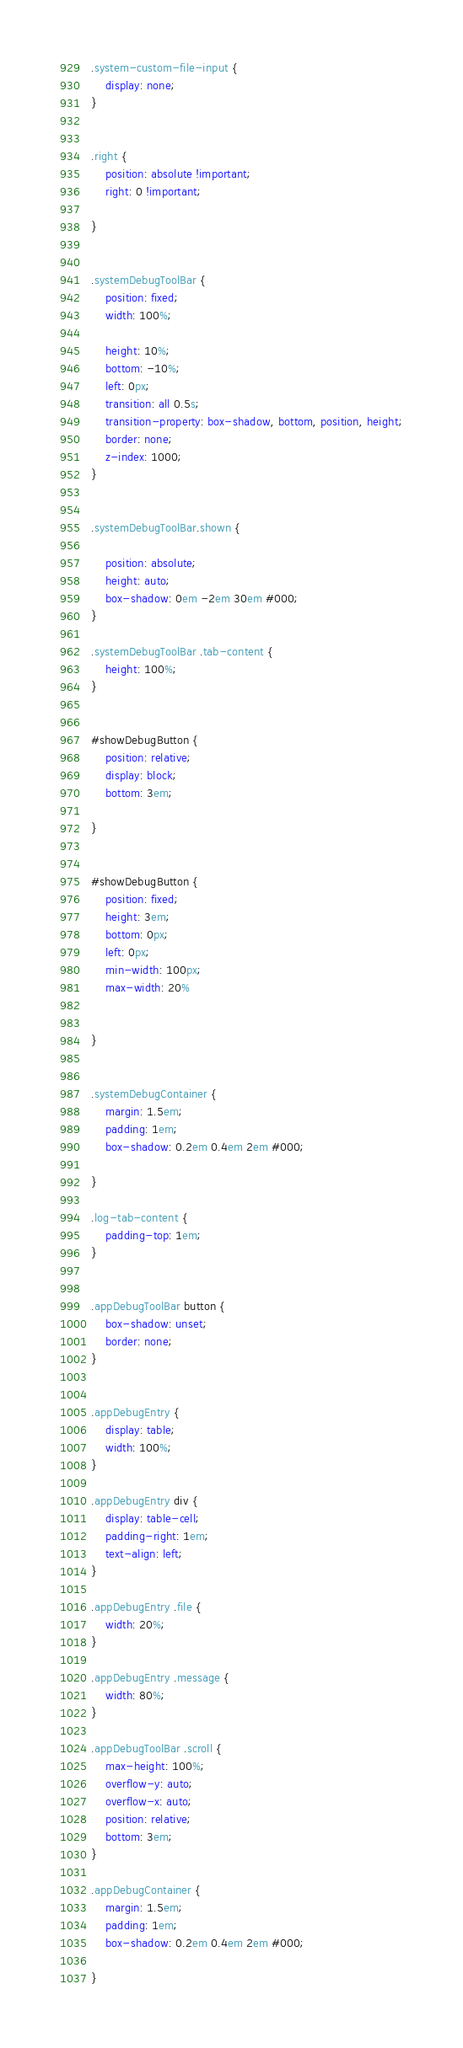<code> <loc_0><loc_0><loc_500><loc_500><_CSS_>.system-custom-file-input {
    display: none;
}


.right {
    position: absolute !important;
    right: 0 !important;

}


.systemDebugToolBar {
    position: fixed;
    width: 100%;

    height: 10%;
    bottom: -10%;
    left: 0px;
    transition: all 0.5s;
    transition-property: box-shadow, bottom, position, height;
    border: none;
    z-index: 1000;
}


.systemDebugToolBar.shown {

    position: absolute;
    height: auto;
    box-shadow: 0em -2em 30em #000;
}

.systemDebugToolBar .tab-content {
    height: 100%;
}


#showDebugButton {
    position: relative;
    display: block;
    bottom: 3em;

}


#showDebugButton {
    position: fixed;
    height: 3em;
    bottom: 0px;
    left: 0px;
    min-width: 100px;
    max-width: 20%


}


.systemDebugContainer {
    margin: 1.5em;
    padding: 1em;
    box-shadow: 0.2em 0.4em 2em #000;

}

.log-tab-content {
    padding-top: 1em;
}


.appDebugToolBar button {
    box-shadow: unset;
    border: none;
}


.appDebugEntry {
    display: table;
    width: 100%;
}

.appDebugEntry div {
    display: table-cell;
    padding-right: 1em;
    text-align: left;
}

.appDebugEntry .file {
    width: 20%;
}

.appDebugEntry .message {
    width: 80%;
}

.appDebugToolBar .scroll {
    max-height: 100%;
    overflow-y: auto;
    overflow-x: auto;
    position: relative;
    bottom: 3em;
}

.appDebugContainer {
    margin: 1.5em;
    padding: 1em;
    box-shadow: 0.2em 0.4em 2em #000;

}</code> 